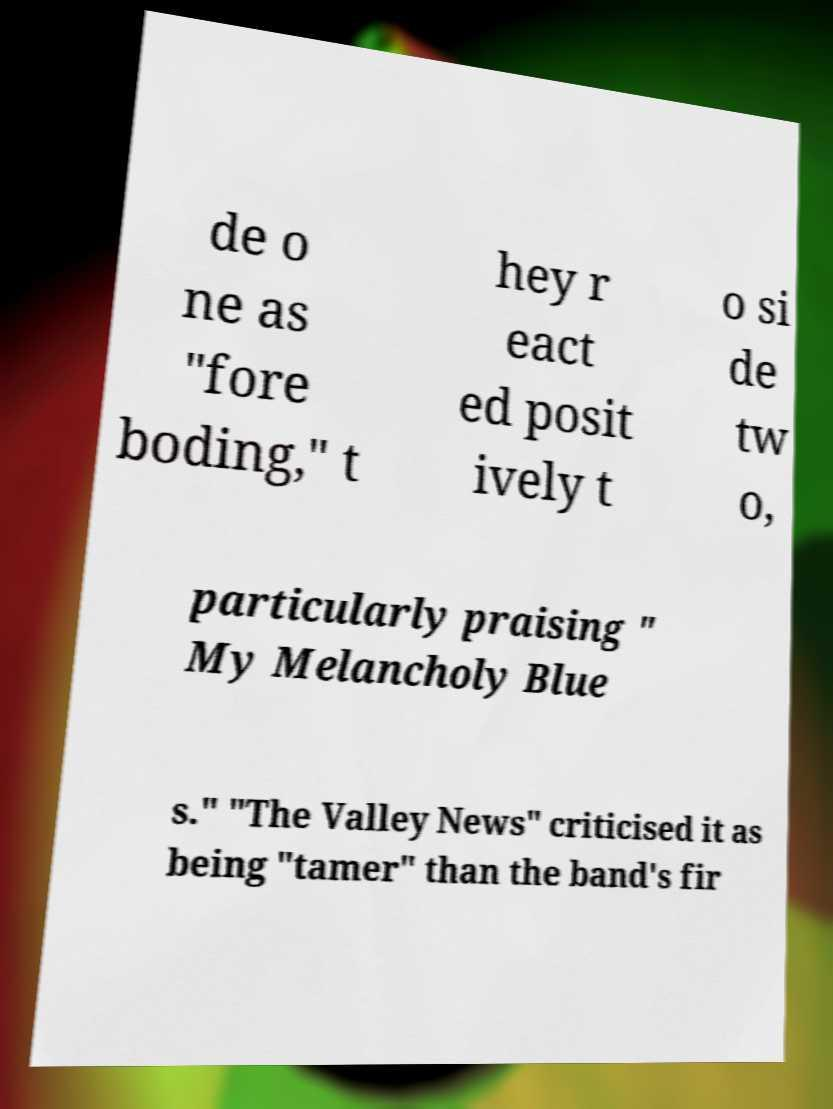What messages or text are displayed in this image? I need them in a readable, typed format. de o ne as "fore boding," t hey r eact ed posit ively t o si de tw o, particularly praising " My Melancholy Blue s." "The Valley News" criticised it as being "tamer" than the band's fir 